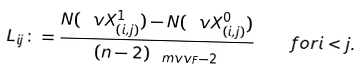<formula> <loc_0><loc_0><loc_500><loc_500>L _ { i j } \colon = \frac { N ( \ v X _ { ( i , j ) } ^ { 1 } ) - N ( \ v X _ { ( i , j ) } ^ { 0 } ) } { ( n - 2 ) _ { \ m v v _ { F } - 2 } } \quad f o r i < j .</formula> 